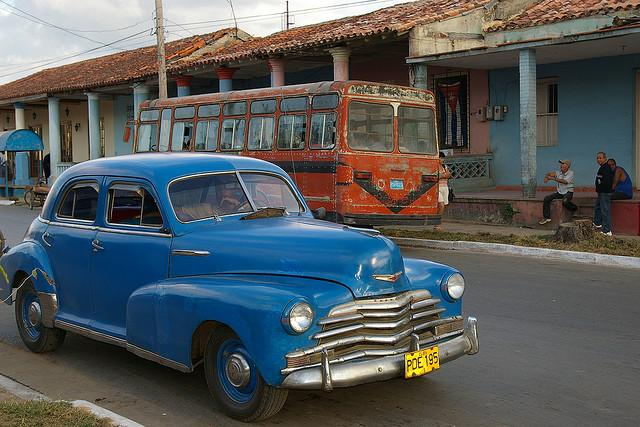Why are the vehicles so old? cuba 